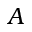Convert formula to latex. <formula><loc_0><loc_0><loc_500><loc_500>A</formula> 